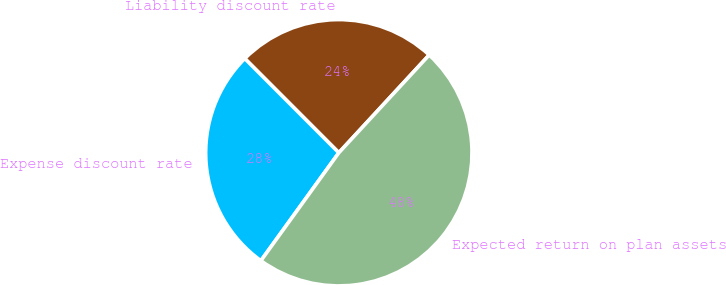Convert chart to OTSL. <chart><loc_0><loc_0><loc_500><loc_500><pie_chart><fcel>Liability discount rate<fcel>Expense discount rate<fcel>Expected return on plan assets<nl><fcel>24.36%<fcel>27.56%<fcel>48.08%<nl></chart> 